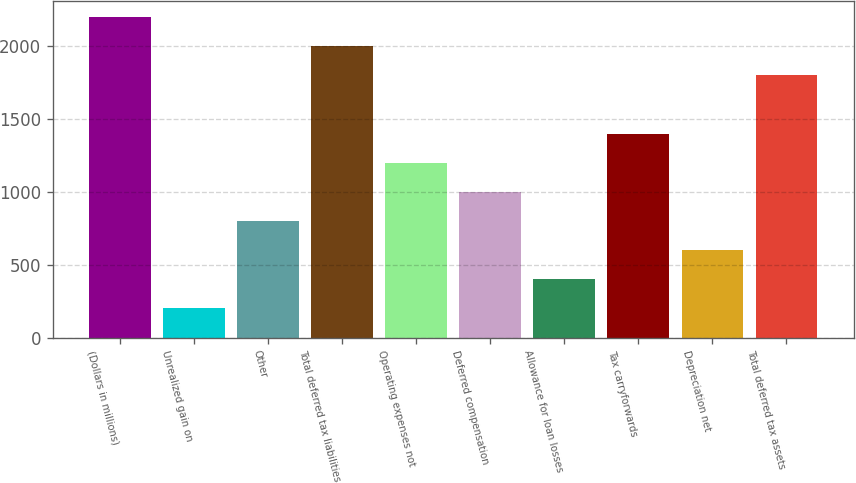Convert chart to OTSL. <chart><loc_0><loc_0><loc_500><loc_500><bar_chart><fcel>(Dollars in millions)<fcel>Unrealized gain on<fcel>Other<fcel>Total deferred tax liabilities<fcel>Operating expenses not<fcel>Deferred compensation<fcel>Allowance for loan losses<fcel>Tax carryforwards<fcel>Depreciation net<fcel>Total deferred tax assets<nl><fcel>2199.7<fcel>202.7<fcel>801.8<fcel>2000<fcel>1201.2<fcel>1001.5<fcel>402.4<fcel>1400.9<fcel>602.1<fcel>1800.3<nl></chart> 